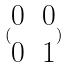Convert formula to latex. <formula><loc_0><loc_0><loc_500><loc_500>( \begin{matrix} 0 & 0 \\ 0 & 1 \end{matrix} )</formula> 